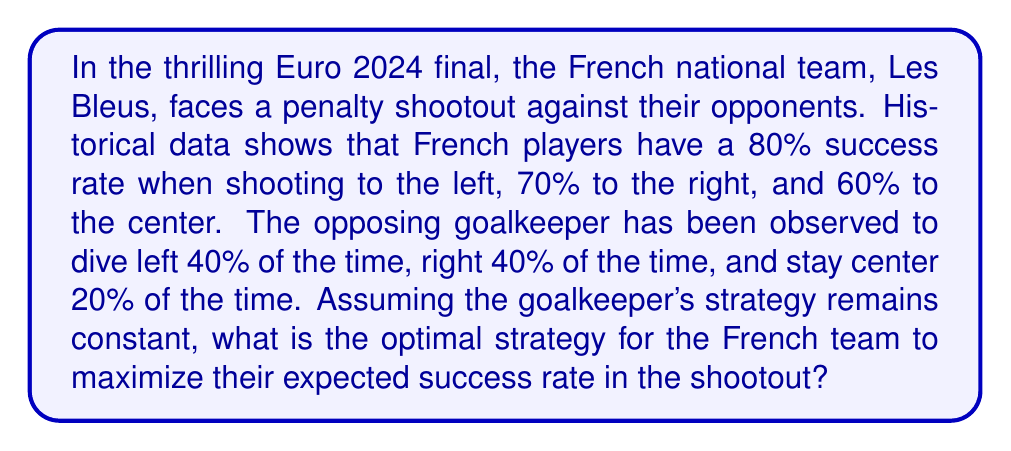Can you solve this math problem? Let's approach this problem using game theory and the concept of expected value:

1) First, we need to calculate the probability of scoring for each combination of player's shot and goalkeeper's action:

   Left shot:
   - If GK dives left: 0% chance (assumed)
   - If GK dives right or stays center: 80% chance

   Right shot:
   - If GK dives right: 0% chance (assumed)
   - If GK dives left or stays center: 70% chance

   Center shot:
   - If GK stays center: 0% chance (assumed)
   - If GK dives left or right: 60% chance

2) Now, let's calculate the expected success rate for each shot direction:

   Left: $0.8 \cdot (0.4 + 0.2) = 0.48$ or 48%
   Right: $0.7 \cdot (0.4 + 0.2) = 0.42$ or 42%
   Center: $0.6 \cdot (0.4 + 0.4) = 0.48$ or 48%

3) To maximize the expected success rate, we should choose the strategy with the highest probability. In this case, there's a tie between shooting left and center, both at 48%.

4) To break the tie, we can consider that shooting left has a higher base success rate (80%) compared to center (60%), which might be preferable in case the goalkeeper's strategy changes.

5) The optimal strategy can be expressed as a probability distribution:

   $$P(\text{Left}) = 0.5$$
   $$P(\text{Center}) = 0.5$$
   $$P(\text{Right}) = 0$$

This means the French players should alternate between shooting left and center, never shooting right.

6) The expected success rate with this strategy is:

   $$0.5 \cdot 0.48 + 0.5 \cdot 0.48 + 0 \cdot 0.42 = 0.48$$ or 48%
Answer: The optimal strategy for the French team is to shoot left 50% of the time and center 50% of the time, never shooting right. This strategy yields an expected success rate of 48%. 